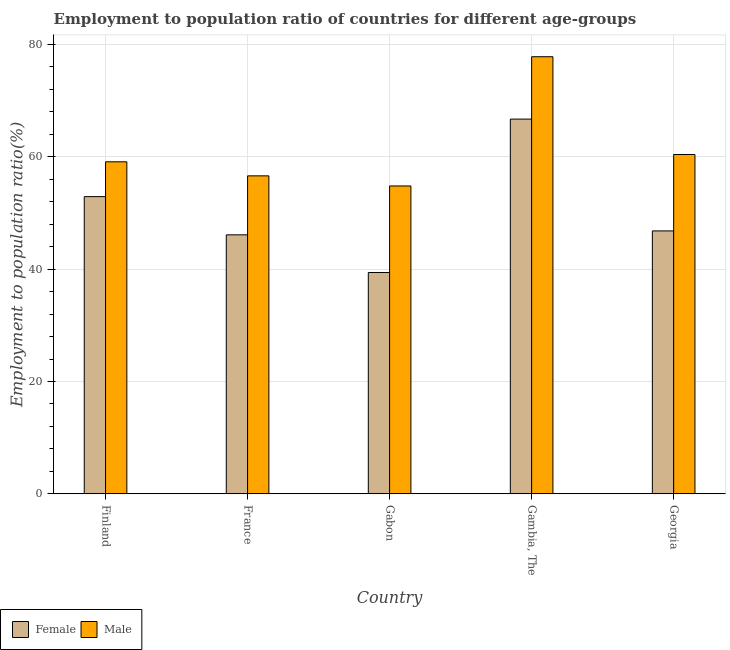How many groups of bars are there?
Provide a short and direct response. 5. How many bars are there on the 2nd tick from the right?
Make the answer very short. 2. What is the label of the 4th group of bars from the left?
Provide a short and direct response. Gambia, The. In how many cases, is the number of bars for a given country not equal to the number of legend labels?
Your answer should be compact. 0. What is the employment to population ratio(male) in Georgia?
Your response must be concise. 60.4. Across all countries, what is the maximum employment to population ratio(female)?
Give a very brief answer. 66.7. Across all countries, what is the minimum employment to population ratio(female)?
Your answer should be compact. 39.4. In which country was the employment to population ratio(male) maximum?
Provide a succinct answer. Gambia, The. In which country was the employment to population ratio(male) minimum?
Keep it short and to the point. Gabon. What is the total employment to population ratio(female) in the graph?
Make the answer very short. 251.9. What is the difference between the employment to population ratio(male) in France and that in Georgia?
Your response must be concise. -3.8. What is the difference between the employment to population ratio(male) in Gambia, The and the employment to population ratio(female) in Finland?
Ensure brevity in your answer.  24.9. What is the average employment to population ratio(female) per country?
Offer a terse response. 50.38. What is the difference between the employment to population ratio(male) and employment to population ratio(female) in Gambia, The?
Offer a very short reply. 11.1. What is the ratio of the employment to population ratio(male) in Finland to that in Georgia?
Give a very brief answer. 0.98. Is the difference between the employment to population ratio(female) in Finland and Gambia, The greater than the difference between the employment to population ratio(male) in Finland and Gambia, The?
Your answer should be compact. Yes. What is the difference between the highest and the second highest employment to population ratio(male)?
Your answer should be compact. 17.4. What is the difference between the highest and the lowest employment to population ratio(female)?
Ensure brevity in your answer.  27.3. What does the 2nd bar from the left in Gambia, The represents?
Offer a very short reply. Male. What does the 1st bar from the right in Gabon represents?
Your answer should be compact. Male. Are all the bars in the graph horizontal?
Provide a succinct answer. No. What is the difference between two consecutive major ticks on the Y-axis?
Give a very brief answer. 20. Does the graph contain grids?
Your answer should be compact. Yes. Where does the legend appear in the graph?
Offer a very short reply. Bottom left. How many legend labels are there?
Offer a very short reply. 2. How are the legend labels stacked?
Offer a terse response. Horizontal. What is the title of the graph?
Your response must be concise. Employment to population ratio of countries for different age-groups. What is the Employment to population ratio(%) in Female in Finland?
Ensure brevity in your answer.  52.9. What is the Employment to population ratio(%) in Male in Finland?
Keep it short and to the point. 59.1. What is the Employment to population ratio(%) of Female in France?
Give a very brief answer. 46.1. What is the Employment to population ratio(%) in Male in France?
Give a very brief answer. 56.6. What is the Employment to population ratio(%) of Female in Gabon?
Provide a succinct answer. 39.4. What is the Employment to population ratio(%) in Male in Gabon?
Provide a succinct answer. 54.8. What is the Employment to population ratio(%) of Female in Gambia, The?
Your response must be concise. 66.7. What is the Employment to population ratio(%) of Male in Gambia, The?
Give a very brief answer. 77.8. What is the Employment to population ratio(%) in Female in Georgia?
Make the answer very short. 46.8. What is the Employment to population ratio(%) of Male in Georgia?
Ensure brevity in your answer.  60.4. Across all countries, what is the maximum Employment to population ratio(%) in Female?
Make the answer very short. 66.7. Across all countries, what is the maximum Employment to population ratio(%) in Male?
Provide a short and direct response. 77.8. Across all countries, what is the minimum Employment to population ratio(%) in Female?
Ensure brevity in your answer.  39.4. Across all countries, what is the minimum Employment to population ratio(%) in Male?
Make the answer very short. 54.8. What is the total Employment to population ratio(%) in Female in the graph?
Keep it short and to the point. 251.9. What is the total Employment to population ratio(%) of Male in the graph?
Offer a very short reply. 308.7. What is the difference between the Employment to population ratio(%) of Female in Finland and that in France?
Provide a short and direct response. 6.8. What is the difference between the Employment to population ratio(%) in Male in Finland and that in France?
Keep it short and to the point. 2.5. What is the difference between the Employment to population ratio(%) of Female in Finland and that in Gabon?
Offer a terse response. 13.5. What is the difference between the Employment to population ratio(%) of Male in Finland and that in Gambia, The?
Provide a succinct answer. -18.7. What is the difference between the Employment to population ratio(%) of Female in Finland and that in Georgia?
Your answer should be very brief. 6.1. What is the difference between the Employment to population ratio(%) of Male in France and that in Gabon?
Make the answer very short. 1.8. What is the difference between the Employment to population ratio(%) of Female in France and that in Gambia, The?
Your response must be concise. -20.6. What is the difference between the Employment to population ratio(%) of Male in France and that in Gambia, The?
Your response must be concise. -21.2. What is the difference between the Employment to population ratio(%) in Female in France and that in Georgia?
Make the answer very short. -0.7. What is the difference between the Employment to population ratio(%) in Female in Gabon and that in Gambia, The?
Your response must be concise. -27.3. What is the difference between the Employment to population ratio(%) of Male in Gabon and that in Gambia, The?
Ensure brevity in your answer.  -23. What is the difference between the Employment to population ratio(%) of Female in Gabon and that in Georgia?
Provide a short and direct response. -7.4. What is the difference between the Employment to population ratio(%) in Female in Gambia, The and that in Georgia?
Your response must be concise. 19.9. What is the difference between the Employment to population ratio(%) in Female in Finland and the Employment to population ratio(%) in Male in Gambia, The?
Provide a short and direct response. -24.9. What is the difference between the Employment to population ratio(%) of Female in France and the Employment to population ratio(%) of Male in Gabon?
Offer a very short reply. -8.7. What is the difference between the Employment to population ratio(%) in Female in France and the Employment to population ratio(%) in Male in Gambia, The?
Make the answer very short. -31.7. What is the difference between the Employment to population ratio(%) in Female in France and the Employment to population ratio(%) in Male in Georgia?
Your answer should be very brief. -14.3. What is the difference between the Employment to population ratio(%) of Female in Gabon and the Employment to population ratio(%) of Male in Gambia, The?
Offer a terse response. -38.4. What is the difference between the Employment to population ratio(%) of Female in Gambia, The and the Employment to population ratio(%) of Male in Georgia?
Offer a very short reply. 6.3. What is the average Employment to population ratio(%) in Female per country?
Your response must be concise. 50.38. What is the average Employment to population ratio(%) of Male per country?
Your answer should be very brief. 61.74. What is the difference between the Employment to population ratio(%) in Female and Employment to population ratio(%) in Male in Gabon?
Ensure brevity in your answer.  -15.4. What is the difference between the Employment to population ratio(%) in Female and Employment to population ratio(%) in Male in Gambia, The?
Provide a succinct answer. -11.1. What is the difference between the Employment to population ratio(%) in Female and Employment to population ratio(%) in Male in Georgia?
Your response must be concise. -13.6. What is the ratio of the Employment to population ratio(%) of Female in Finland to that in France?
Your answer should be compact. 1.15. What is the ratio of the Employment to population ratio(%) of Male in Finland to that in France?
Provide a short and direct response. 1.04. What is the ratio of the Employment to population ratio(%) in Female in Finland to that in Gabon?
Make the answer very short. 1.34. What is the ratio of the Employment to population ratio(%) of Male in Finland to that in Gabon?
Ensure brevity in your answer.  1.08. What is the ratio of the Employment to population ratio(%) in Female in Finland to that in Gambia, The?
Provide a short and direct response. 0.79. What is the ratio of the Employment to population ratio(%) of Male in Finland to that in Gambia, The?
Your response must be concise. 0.76. What is the ratio of the Employment to population ratio(%) in Female in Finland to that in Georgia?
Give a very brief answer. 1.13. What is the ratio of the Employment to population ratio(%) in Male in Finland to that in Georgia?
Offer a very short reply. 0.98. What is the ratio of the Employment to population ratio(%) in Female in France to that in Gabon?
Keep it short and to the point. 1.17. What is the ratio of the Employment to population ratio(%) in Male in France to that in Gabon?
Your answer should be compact. 1.03. What is the ratio of the Employment to population ratio(%) in Female in France to that in Gambia, The?
Your answer should be compact. 0.69. What is the ratio of the Employment to population ratio(%) of Male in France to that in Gambia, The?
Offer a terse response. 0.73. What is the ratio of the Employment to population ratio(%) in Male in France to that in Georgia?
Provide a short and direct response. 0.94. What is the ratio of the Employment to population ratio(%) in Female in Gabon to that in Gambia, The?
Ensure brevity in your answer.  0.59. What is the ratio of the Employment to population ratio(%) in Male in Gabon to that in Gambia, The?
Give a very brief answer. 0.7. What is the ratio of the Employment to population ratio(%) of Female in Gabon to that in Georgia?
Offer a terse response. 0.84. What is the ratio of the Employment to population ratio(%) in Male in Gabon to that in Georgia?
Ensure brevity in your answer.  0.91. What is the ratio of the Employment to population ratio(%) in Female in Gambia, The to that in Georgia?
Offer a very short reply. 1.43. What is the ratio of the Employment to population ratio(%) in Male in Gambia, The to that in Georgia?
Your response must be concise. 1.29. What is the difference between the highest and the second highest Employment to population ratio(%) of Male?
Give a very brief answer. 17.4. What is the difference between the highest and the lowest Employment to population ratio(%) in Female?
Provide a succinct answer. 27.3. 